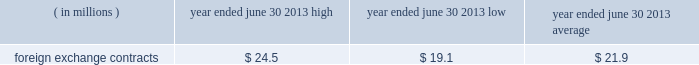Currencies of major industrial countries .
We may also enter into foreign currency option contracts to hedge anticipated transactions where there is a high probability that anticipated exposures will materialize .
The foreign currency forward contracts entered into to hedge antici- pated transactions have been designated as foreign currency cash-flow hedges and have varying maturities through the end of march 2015 .
Hedge effectiveness of foreign currency forward contracts is based on a hypo- thetical derivative methodology and excludes the portion of fair value attributable to the spot-forward difference which is recorded in current-period earnings .
Hedge effectiveness of foreign currency option contracts is based on a dollar offset methodology .
The ineffective portion of both foreign currency forward and option con- tracts is recorded in current-period earnings .
For hedge contracts that are no longer deemed highly effective , hedge accounting is discontinued and gains and losses accumulated in other comprehensive income ( loss ) are reclassified to earnings when the underlying forecasted transaction occurs .
If it is probable that the forecasted transaction will no longer occur , then any gains or losses in accumulated other comprehensive income ( loss ) are reclassified to current-period earnings .
As of june 30 , 2013 , these foreign currency cash-flow hedges were highly effective in all material respects .
At june 30 , 2013 , we had foreign currency forward contracts in the amount of $ 1579.6 million .
The foreign currencies included in foreign currency forward contracts ( notional value stated in u.s .
Dollars ) are principally the british pound ( $ 426.2 million ) , euro ( $ 268.8 million ) , canadian dollar ( $ 198.6 million ) , swiss franc ( $ 111.5 mil- lion ) , australian dollar ( $ 92.1 million ) , thailand baht ( $ 75.5 million ) and hong kong dollar ( $ 58.1 million ) .
Credit risk as a matter of policy , we only enter into derivative con- tracts with counterparties that have a long-term credit rat- ing of at least a- or higher by at least two nationally recognized rating agencies .
The counterparties to these contracts are major financial institutions .
Exposure to credit risk in the event of nonperformance by any of the counterparties is limited to the gross fair value of con- tracts in asset positions , which totaled $ 21.7 million at june 30 , 2013 .
To manage this risk , we have established counterparty credit guidelines that are continually moni- tored .
Accordingly , management believes risk of loss under these hedging contracts is remote .
Certain of our derivative financial instruments contain credit-risk-related contingent features .
At june 30 , 2013 , we were in a net asset position for certain derivative contracts that contain such features with two counter- parties .
The fair value of those contracts as of june 30 , 2013 was approximately $ 4.6 million .
As of june 30 , 2013 , we were in compliance with such credit-risk-related contingent features .
Market risk we use a value-at-risk model to assess the market risk of our derivative financial instruments .
Value-at-risk repre- sents the potential losses for an instrument or portfolio from adverse changes in market factors for a specified time period and confidence level .
We estimate value-at- risk across all of our derivative financial instruments using a model with historical volatilities and correlations calcu- lated over the past 250-day period .
The high , low and average measured value-at-risk during fiscal 2013 related to our foreign exchange contracts is as follows: .
Foreign exchange contracts $ 24.5 $ 19.1 $ 21.9 the model estimates were made assuming normal market conditions and a 95 percent confidence level .
We used a statistical simulation model that valued our derivative financial instruments against one thousand randomly gen- erated market price paths .
Our calculated value-at-risk exposure represents an estimate of reasonably possible net losses that would be recognized on our portfolio of derivative financial instruments assuming hypothetical movements in future market rates and is not necessarily indicative of actual results , which may or may not occur .
It does not represent the maximum possible loss or any expected loss that may occur , since actual future gains and losses will differ from those estimated , based upon actual fluctuations in market rates , operating exposures , and the timing thereof , and changes in our portfolio of derivative financial instruments during the year .
We believe , however , that any such loss incurred would be offset by the effects of market rate movements on the respective underlying transactions for which the deriva- tive financial instrument was intended .
Off-balance sheet arrangements we do not maintain any off-balance sheet arrangements , transactions , obligations or other relationships with unconsolidated entities , other than operating leases , that would be expected to have a material current or future effect upon our financial condition or results of operations .
The est{e lauder companies inc .
135 .
What is the percentage of the british pound among the total foreign currency forward contracts? 
Rationale: it is the number of dollars in the british pound divided by the total amount of foreign currency forward contracts .
Computations: (426.2 / 1579.6)
Answer: 0.26982. 